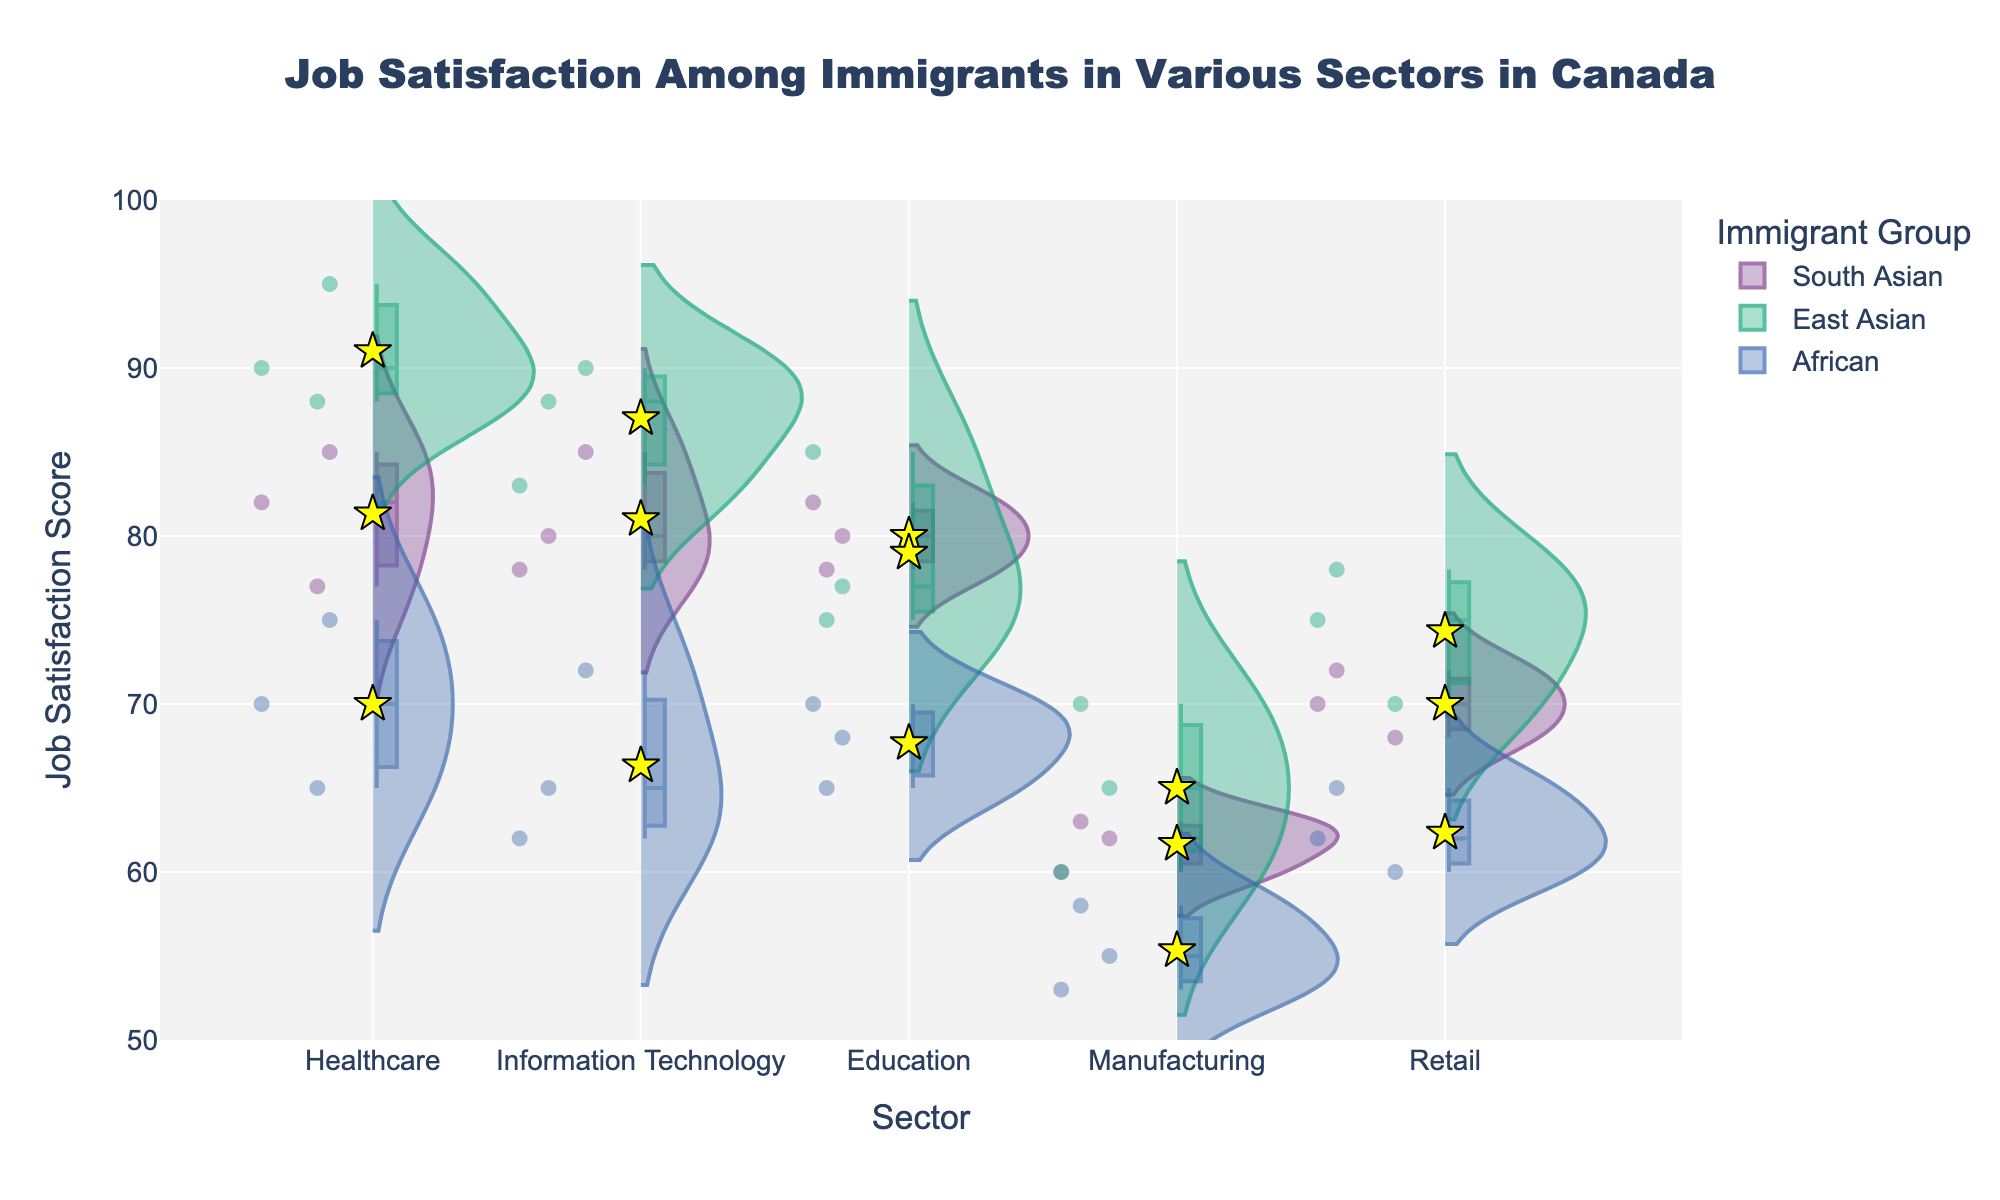What is the highest job satisfaction score for South Asian immigrants in the Healthcare sector? Looking at the Healthcare sector for South Asian immigrants, the highest point in the violin plot is 85.
Answer: 85 How many sectors are included in the chart? The x-axis lists the sectors plotted, counting them gives: Healthcare, Information Technology, Education, Manufacturing, and Retail.
Answer: 5 Which immigrant group has the highest overall job satisfaction in Manufacturing? For the Manufacturing sector, the yellow star marker representing the mean value for East Asian immigrants is the highest among the groups.
Answer: East Asian Compare the mean job satisfaction scores of South Asian immigrants in Information Technology and Retail sectors. The yellow stars, which indicate mean scores, show that the South Asian group's mean in Information Technology is higher than in Retail.
Answer: Information Technology is higher What is the title of the chart? The title is displayed at the top of the chart and reads: "Job Satisfaction Among Immigrants in Various Sectors in Canada".
Answer: Job Satisfaction Among Immigrants in Various Sectors in Canada Which sector has the largest spread in job satisfaction scores for East Asian immigrants? The width of the violin plot indicates the spread, and East Asian immigrants in the Healthcare sector show the widest plot.
Answer: Healthcare For African immigrants, what is the median job satisfaction score in Retail? The box plot within the violin shows the median as the line, and for African immigrants in Retail, it is at 62.
Answer: 62 Among the sectors, which one has the lowest mean job satisfaction for South Asian immigrants? The yellow star markers show that Manufacturing has the lowest mean job satisfaction score among sectors for South Asian immigrants.
Answer: Manufacturing What is the mean job satisfaction score for African immigrants in the Education sector? Find the mean marker (yellow star) in the Education sector for African immigrants; it is around 67.7 (calculated as (65+70+68)/3).
Answer: 67.7 What is the range of job satisfaction scores for East Asian immigrants in the Information Technology sector? The values range from around 83 to 90 in the Information Technology sector for East Asian immigrants.
Answer: 83 to 90 